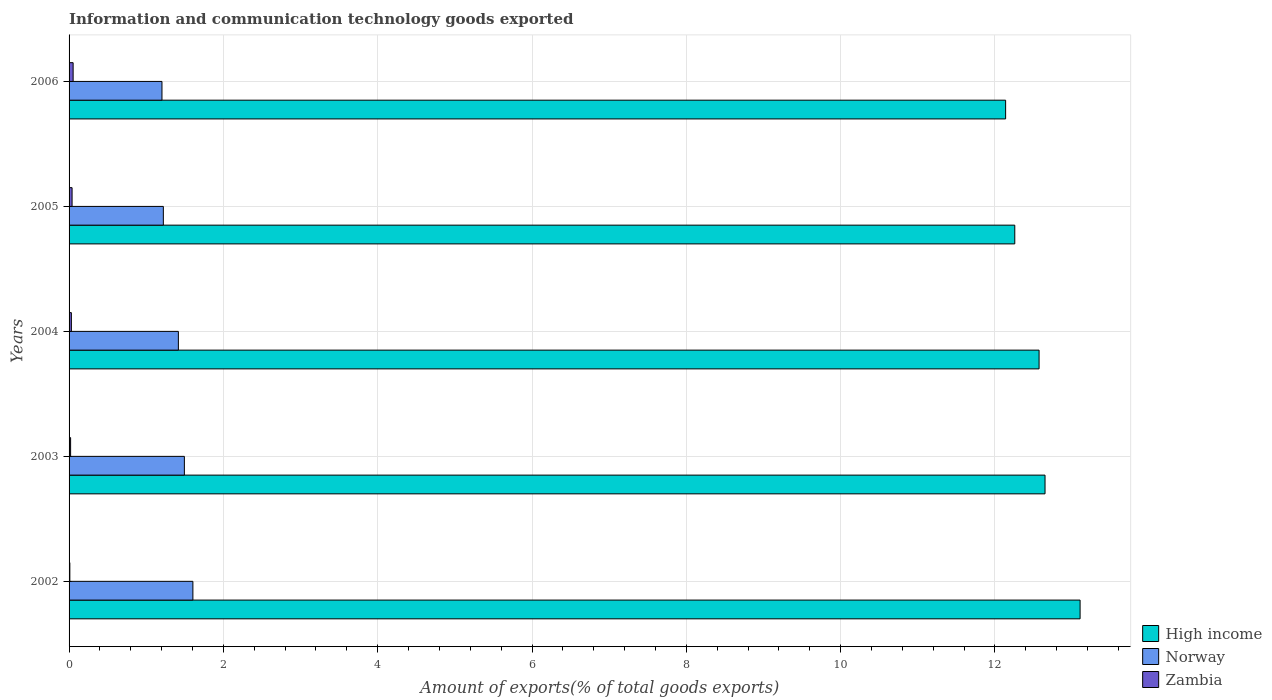How many groups of bars are there?
Your answer should be compact. 5. Are the number of bars on each tick of the Y-axis equal?
Make the answer very short. Yes. How many bars are there on the 5th tick from the top?
Give a very brief answer. 3. What is the label of the 3rd group of bars from the top?
Offer a very short reply. 2004. What is the amount of goods exported in Norway in 2003?
Make the answer very short. 1.49. Across all years, what is the maximum amount of goods exported in Zambia?
Keep it short and to the point. 0.05. Across all years, what is the minimum amount of goods exported in Zambia?
Your answer should be very brief. 0.01. In which year was the amount of goods exported in Norway minimum?
Give a very brief answer. 2006. What is the total amount of goods exported in Norway in the graph?
Keep it short and to the point. 6.94. What is the difference between the amount of goods exported in High income in 2002 and that in 2005?
Offer a terse response. 0.85. What is the difference between the amount of goods exported in Norway in 2004 and the amount of goods exported in Zambia in 2002?
Your answer should be very brief. 1.41. What is the average amount of goods exported in Zambia per year?
Your response must be concise. 0.03. In the year 2006, what is the difference between the amount of goods exported in High income and amount of goods exported in Zambia?
Give a very brief answer. 12.09. What is the ratio of the amount of goods exported in High income in 2004 to that in 2005?
Give a very brief answer. 1.03. Is the difference between the amount of goods exported in High income in 2002 and 2003 greater than the difference between the amount of goods exported in Zambia in 2002 and 2003?
Your response must be concise. Yes. What is the difference between the highest and the second highest amount of goods exported in High income?
Your answer should be compact. 0.45. What is the difference between the highest and the lowest amount of goods exported in High income?
Offer a terse response. 0.97. In how many years, is the amount of goods exported in Norway greater than the average amount of goods exported in Norway taken over all years?
Keep it short and to the point. 3. Is the sum of the amount of goods exported in Zambia in 2002 and 2003 greater than the maximum amount of goods exported in High income across all years?
Provide a succinct answer. No. What does the 1st bar from the top in 2005 represents?
Give a very brief answer. Zambia. What does the 1st bar from the bottom in 2005 represents?
Provide a short and direct response. High income. Is it the case that in every year, the sum of the amount of goods exported in Norway and amount of goods exported in High income is greater than the amount of goods exported in Zambia?
Ensure brevity in your answer.  Yes. How many bars are there?
Offer a terse response. 15. How many years are there in the graph?
Keep it short and to the point. 5. What is the difference between two consecutive major ticks on the X-axis?
Provide a succinct answer. 2. Are the values on the major ticks of X-axis written in scientific E-notation?
Make the answer very short. No. Where does the legend appear in the graph?
Offer a terse response. Bottom right. What is the title of the graph?
Your answer should be very brief. Information and communication technology goods exported. Does "Least developed countries" appear as one of the legend labels in the graph?
Your answer should be compact. No. What is the label or title of the X-axis?
Your answer should be very brief. Amount of exports(% of total goods exports). What is the label or title of the Y-axis?
Provide a short and direct response. Years. What is the Amount of exports(% of total goods exports) in High income in 2002?
Your response must be concise. 13.1. What is the Amount of exports(% of total goods exports) of Norway in 2002?
Provide a succinct answer. 1.6. What is the Amount of exports(% of total goods exports) in Zambia in 2002?
Provide a succinct answer. 0.01. What is the Amount of exports(% of total goods exports) of High income in 2003?
Give a very brief answer. 12.65. What is the Amount of exports(% of total goods exports) of Norway in 2003?
Your response must be concise. 1.49. What is the Amount of exports(% of total goods exports) in Zambia in 2003?
Offer a very short reply. 0.02. What is the Amount of exports(% of total goods exports) of High income in 2004?
Your answer should be very brief. 12.57. What is the Amount of exports(% of total goods exports) of Norway in 2004?
Your answer should be very brief. 1.42. What is the Amount of exports(% of total goods exports) in Zambia in 2004?
Provide a short and direct response. 0.03. What is the Amount of exports(% of total goods exports) of High income in 2005?
Offer a terse response. 12.26. What is the Amount of exports(% of total goods exports) of Norway in 2005?
Your answer should be compact. 1.22. What is the Amount of exports(% of total goods exports) of Zambia in 2005?
Provide a short and direct response. 0.04. What is the Amount of exports(% of total goods exports) in High income in 2006?
Offer a terse response. 12.14. What is the Amount of exports(% of total goods exports) in Norway in 2006?
Keep it short and to the point. 1.2. What is the Amount of exports(% of total goods exports) in Zambia in 2006?
Provide a succinct answer. 0.05. Across all years, what is the maximum Amount of exports(% of total goods exports) of High income?
Give a very brief answer. 13.1. Across all years, what is the maximum Amount of exports(% of total goods exports) of Norway?
Provide a short and direct response. 1.6. Across all years, what is the maximum Amount of exports(% of total goods exports) of Zambia?
Your response must be concise. 0.05. Across all years, what is the minimum Amount of exports(% of total goods exports) of High income?
Ensure brevity in your answer.  12.14. Across all years, what is the minimum Amount of exports(% of total goods exports) in Norway?
Provide a succinct answer. 1.2. Across all years, what is the minimum Amount of exports(% of total goods exports) of Zambia?
Provide a succinct answer. 0.01. What is the total Amount of exports(% of total goods exports) in High income in the graph?
Give a very brief answer. 62.72. What is the total Amount of exports(% of total goods exports) in Norway in the graph?
Provide a succinct answer. 6.94. What is the total Amount of exports(% of total goods exports) in Zambia in the graph?
Offer a very short reply. 0.15. What is the difference between the Amount of exports(% of total goods exports) of High income in 2002 and that in 2003?
Ensure brevity in your answer.  0.45. What is the difference between the Amount of exports(% of total goods exports) of Norway in 2002 and that in 2003?
Give a very brief answer. 0.11. What is the difference between the Amount of exports(% of total goods exports) in Zambia in 2002 and that in 2003?
Offer a terse response. -0.01. What is the difference between the Amount of exports(% of total goods exports) of High income in 2002 and that in 2004?
Your answer should be compact. 0.53. What is the difference between the Amount of exports(% of total goods exports) of Norway in 2002 and that in 2004?
Keep it short and to the point. 0.19. What is the difference between the Amount of exports(% of total goods exports) in Zambia in 2002 and that in 2004?
Give a very brief answer. -0.02. What is the difference between the Amount of exports(% of total goods exports) in High income in 2002 and that in 2005?
Offer a terse response. 0.85. What is the difference between the Amount of exports(% of total goods exports) in Norway in 2002 and that in 2005?
Make the answer very short. 0.38. What is the difference between the Amount of exports(% of total goods exports) of Zambia in 2002 and that in 2005?
Make the answer very short. -0.03. What is the difference between the Amount of exports(% of total goods exports) of High income in 2002 and that in 2006?
Your answer should be compact. 0.97. What is the difference between the Amount of exports(% of total goods exports) of Norway in 2002 and that in 2006?
Your answer should be compact. 0.4. What is the difference between the Amount of exports(% of total goods exports) in Zambia in 2002 and that in 2006?
Keep it short and to the point. -0.04. What is the difference between the Amount of exports(% of total goods exports) of High income in 2003 and that in 2004?
Offer a terse response. 0.08. What is the difference between the Amount of exports(% of total goods exports) of Norway in 2003 and that in 2004?
Your answer should be very brief. 0.08. What is the difference between the Amount of exports(% of total goods exports) of Zambia in 2003 and that in 2004?
Ensure brevity in your answer.  -0.01. What is the difference between the Amount of exports(% of total goods exports) in High income in 2003 and that in 2005?
Make the answer very short. 0.39. What is the difference between the Amount of exports(% of total goods exports) of Norway in 2003 and that in 2005?
Provide a short and direct response. 0.27. What is the difference between the Amount of exports(% of total goods exports) in Zambia in 2003 and that in 2005?
Your answer should be compact. -0.02. What is the difference between the Amount of exports(% of total goods exports) in High income in 2003 and that in 2006?
Keep it short and to the point. 0.51. What is the difference between the Amount of exports(% of total goods exports) in Norway in 2003 and that in 2006?
Provide a succinct answer. 0.29. What is the difference between the Amount of exports(% of total goods exports) of Zambia in 2003 and that in 2006?
Provide a short and direct response. -0.03. What is the difference between the Amount of exports(% of total goods exports) of High income in 2004 and that in 2005?
Keep it short and to the point. 0.31. What is the difference between the Amount of exports(% of total goods exports) of Norway in 2004 and that in 2005?
Ensure brevity in your answer.  0.19. What is the difference between the Amount of exports(% of total goods exports) in Zambia in 2004 and that in 2005?
Provide a succinct answer. -0.01. What is the difference between the Amount of exports(% of total goods exports) of High income in 2004 and that in 2006?
Make the answer very short. 0.43. What is the difference between the Amount of exports(% of total goods exports) of Norway in 2004 and that in 2006?
Keep it short and to the point. 0.21. What is the difference between the Amount of exports(% of total goods exports) in Zambia in 2004 and that in 2006?
Offer a very short reply. -0.02. What is the difference between the Amount of exports(% of total goods exports) of High income in 2005 and that in 2006?
Offer a terse response. 0.12. What is the difference between the Amount of exports(% of total goods exports) of Norway in 2005 and that in 2006?
Offer a very short reply. 0.02. What is the difference between the Amount of exports(% of total goods exports) in Zambia in 2005 and that in 2006?
Make the answer very short. -0.01. What is the difference between the Amount of exports(% of total goods exports) of High income in 2002 and the Amount of exports(% of total goods exports) of Norway in 2003?
Provide a short and direct response. 11.61. What is the difference between the Amount of exports(% of total goods exports) of High income in 2002 and the Amount of exports(% of total goods exports) of Zambia in 2003?
Keep it short and to the point. 13.08. What is the difference between the Amount of exports(% of total goods exports) in Norway in 2002 and the Amount of exports(% of total goods exports) in Zambia in 2003?
Provide a short and direct response. 1.58. What is the difference between the Amount of exports(% of total goods exports) of High income in 2002 and the Amount of exports(% of total goods exports) of Norway in 2004?
Keep it short and to the point. 11.69. What is the difference between the Amount of exports(% of total goods exports) in High income in 2002 and the Amount of exports(% of total goods exports) in Zambia in 2004?
Offer a very short reply. 13.07. What is the difference between the Amount of exports(% of total goods exports) in Norway in 2002 and the Amount of exports(% of total goods exports) in Zambia in 2004?
Provide a short and direct response. 1.57. What is the difference between the Amount of exports(% of total goods exports) in High income in 2002 and the Amount of exports(% of total goods exports) in Norway in 2005?
Provide a short and direct response. 11.88. What is the difference between the Amount of exports(% of total goods exports) in High income in 2002 and the Amount of exports(% of total goods exports) in Zambia in 2005?
Ensure brevity in your answer.  13.06. What is the difference between the Amount of exports(% of total goods exports) of Norway in 2002 and the Amount of exports(% of total goods exports) of Zambia in 2005?
Your answer should be compact. 1.57. What is the difference between the Amount of exports(% of total goods exports) in High income in 2002 and the Amount of exports(% of total goods exports) in Norway in 2006?
Your answer should be compact. 11.9. What is the difference between the Amount of exports(% of total goods exports) in High income in 2002 and the Amount of exports(% of total goods exports) in Zambia in 2006?
Ensure brevity in your answer.  13.05. What is the difference between the Amount of exports(% of total goods exports) of Norway in 2002 and the Amount of exports(% of total goods exports) of Zambia in 2006?
Offer a very short reply. 1.55. What is the difference between the Amount of exports(% of total goods exports) in High income in 2003 and the Amount of exports(% of total goods exports) in Norway in 2004?
Your answer should be very brief. 11.23. What is the difference between the Amount of exports(% of total goods exports) in High income in 2003 and the Amount of exports(% of total goods exports) in Zambia in 2004?
Your answer should be compact. 12.62. What is the difference between the Amount of exports(% of total goods exports) of Norway in 2003 and the Amount of exports(% of total goods exports) of Zambia in 2004?
Your answer should be compact. 1.46. What is the difference between the Amount of exports(% of total goods exports) in High income in 2003 and the Amount of exports(% of total goods exports) in Norway in 2005?
Keep it short and to the point. 11.43. What is the difference between the Amount of exports(% of total goods exports) in High income in 2003 and the Amount of exports(% of total goods exports) in Zambia in 2005?
Give a very brief answer. 12.61. What is the difference between the Amount of exports(% of total goods exports) in Norway in 2003 and the Amount of exports(% of total goods exports) in Zambia in 2005?
Ensure brevity in your answer.  1.46. What is the difference between the Amount of exports(% of total goods exports) of High income in 2003 and the Amount of exports(% of total goods exports) of Norway in 2006?
Keep it short and to the point. 11.45. What is the difference between the Amount of exports(% of total goods exports) in High income in 2003 and the Amount of exports(% of total goods exports) in Zambia in 2006?
Make the answer very short. 12.6. What is the difference between the Amount of exports(% of total goods exports) in Norway in 2003 and the Amount of exports(% of total goods exports) in Zambia in 2006?
Give a very brief answer. 1.44. What is the difference between the Amount of exports(% of total goods exports) in High income in 2004 and the Amount of exports(% of total goods exports) in Norway in 2005?
Provide a short and direct response. 11.35. What is the difference between the Amount of exports(% of total goods exports) in High income in 2004 and the Amount of exports(% of total goods exports) in Zambia in 2005?
Give a very brief answer. 12.53. What is the difference between the Amount of exports(% of total goods exports) of Norway in 2004 and the Amount of exports(% of total goods exports) of Zambia in 2005?
Offer a terse response. 1.38. What is the difference between the Amount of exports(% of total goods exports) of High income in 2004 and the Amount of exports(% of total goods exports) of Norway in 2006?
Make the answer very short. 11.37. What is the difference between the Amount of exports(% of total goods exports) of High income in 2004 and the Amount of exports(% of total goods exports) of Zambia in 2006?
Provide a short and direct response. 12.52. What is the difference between the Amount of exports(% of total goods exports) of Norway in 2004 and the Amount of exports(% of total goods exports) of Zambia in 2006?
Make the answer very short. 1.36. What is the difference between the Amount of exports(% of total goods exports) in High income in 2005 and the Amount of exports(% of total goods exports) in Norway in 2006?
Keep it short and to the point. 11.05. What is the difference between the Amount of exports(% of total goods exports) of High income in 2005 and the Amount of exports(% of total goods exports) of Zambia in 2006?
Make the answer very short. 12.2. What is the difference between the Amount of exports(% of total goods exports) in Norway in 2005 and the Amount of exports(% of total goods exports) in Zambia in 2006?
Make the answer very short. 1.17. What is the average Amount of exports(% of total goods exports) in High income per year?
Provide a succinct answer. 12.54. What is the average Amount of exports(% of total goods exports) in Norway per year?
Offer a terse response. 1.39. What is the average Amount of exports(% of total goods exports) of Zambia per year?
Make the answer very short. 0.03. In the year 2002, what is the difference between the Amount of exports(% of total goods exports) in High income and Amount of exports(% of total goods exports) in Norway?
Provide a short and direct response. 11.5. In the year 2002, what is the difference between the Amount of exports(% of total goods exports) of High income and Amount of exports(% of total goods exports) of Zambia?
Offer a terse response. 13.09. In the year 2002, what is the difference between the Amount of exports(% of total goods exports) in Norway and Amount of exports(% of total goods exports) in Zambia?
Your answer should be very brief. 1.59. In the year 2003, what is the difference between the Amount of exports(% of total goods exports) in High income and Amount of exports(% of total goods exports) in Norway?
Keep it short and to the point. 11.15. In the year 2003, what is the difference between the Amount of exports(% of total goods exports) in High income and Amount of exports(% of total goods exports) in Zambia?
Offer a very short reply. 12.63. In the year 2003, what is the difference between the Amount of exports(% of total goods exports) of Norway and Amount of exports(% of total goods exports) of Zambia?
Provide a succinct answer. 1.47. In the year 2004, what is the difference between the Amount of exports(% of total goods exports) of High income and Amount of exports(% of total goods exports) of Norway?
Your answer should be very brief. 11.16. In the year 2004, what is the difference between the Amount of exports(% of total goods exports) in High income and Amount of exports(% of total goods exports) in Zambia?
Provide a short and direct response. 12.54. In the year 2004, what is the difference between the Amount of exports(% of total goods exports) in Norway and Amount of exports(% of total goods exports) in Zambia?
Ensure brevity in your answer.  1.39. In the year 2005, what is the difference between the Amount of exports(% of total goods exports) of High income and Amount of exports(% of total goods exports) of Norway?
Provide a short and direct response. 11.04. In the year 2005, what is the difference between the Amount of exports(% of total goods exports) of High income and Amount of exports(% of total goods exports) of Zambia?
Your answer should be compact. 12.22. In the year 2005, what is the difference between the Amount of exports(% of total goods exports) of Norway and Amount of exports(% of total goods exports) of Zambia?
Provide a succinct answer. 1.18. In the year 2006, what is the difference between the Amount of exports(% of total goods exports) of High income and Amount of exports(% of total goods exports) of Norway?
Provide a short and direct response. 10.93. In the year 2006, what is the difference between the Amount of exports(% of total goods exports) in High income and Amount of exports(% of total goods exports) in Zambia?
Make the answer very short. 12.09. In the year 2006, what is the difference between the Amount of exports(% of total goods exports) in Norway and Amount of exports(% of total goods exports) in Zambia?
Offer a terse response. 1.15. What is the ratio of the Amount of exports(% of total goods exports) of High income in 2002 to that in 2003?
Offer a very short reply. 1.04. What is the ratio of the Amount of exports(% of total goods exports) in Norway in 2002 to that in 2003?
Give a very brief answer. 1.07. What is the ratio of the Amount of exports(% of total goods exports) in Zambia in 2002 to that in 2003?
Make the answer very short. 0.5. What is the ratio of the Amount of exports(% of total goods exports) of High income in 2002 to that in 2004?
Offer a terse response. 1.04. What is the ratio of the Amount of exports(% of total goods exports) in Norway in 2002 to that in 2004?
Give a very brief answer. 1.13. What is the ratio of the Amount of exports(% of total goods exports) of Zambia in 2002 to that in 2004?
Ensure brevity in your answer.  0.33. What is the ratio of the Amount of exports(% of total goods exports) of High income in 2002 to that in 2005?
Provide a short and direct response. 1.07. What is the ratio of the Amount of exports(% of total goods exports) in Norway in 2002 to that in 2005?
Offer a terse response. 1.31. What is the ratio of the Amount of exports(% of total goods exports) of Zambia in 2002 to that in 2005?
Offer a very short reply. 0.26. What is the ratio of the Amount of exports(% of total goods exports) in High income in 2002 to that in 2006?
Offer a terse response. 1.08. What is the ratio of the Amount of exports(% of total goods exports) in Norway in 2002 to that in 2006?
Your answer should be very brief. 1.33. What is the ratio of the Amount of exports(% of total goods exports) in Zambia in 2002 to that in 2006?
Your answer should be very brief. 0.19. What is the ratio of the Amount of exports(% of total goods exports) of High income in 2003 to that in 2004?
Keep it short and to the point. 1.01. What is the ratio of the Amount of exports(% of total goods exports) of Norway in 2003 to that in 2004?
Make the answer very short. 1.05. What is the ratio of the Amount of exports(% of total goods exports) in Zambia in 2003 to that in 2004?
Your response must be concise. 0.67. What is the ratio of the Amount of exports(% of total goods exports) in High income in 2003 to that in 2005?
Offer a terse response. 1.03. What is the ratio of the Amount of exports(% of total goods exports) of Norway in 2003 to that in 2005?
Offer a terse response. 1.22. What is the ratio of the Amount of exports(% of total goods exports) in Zambia in 2003 to that in 2005?
Provide a short and direct response. 0.51. What is the ratio of the Amount of exports(% of total goods exports) in High income in 2003 to that in 2006?
Make the answer very short. 1.04. What is the ratio of the Amount of exports(% of total goods exports) in Norway in 2003 to that in 2006?
Your response must be concise. 1.24. What is the ratio of the Amount of exports(% of total goods exports) in Zambia in 2003 to that in 2006?
Provide a short and direct response. 0.38. What is the ratio of the Amount of exports(% of total goods exports) of High income in 2004 to that in 2005?
Your answer should be very brief. 1.03. What is the ratio of the Amount of exports(% of total goods exports) of Norway in 2004 to that in 2005?
Give a very brief answer. 1.16. What is the ratio of the Amount of exports(% of total goods exports) of Zambia in 2004 to that in 2005?
Make the answer very short. 0.77. What is the ratio of the Amount of exports(% of total goods exports) of High income in 2004 to that in 2006?
Ensure brevity in your answer.  1.04. What is the ratio of the Amount of exports(% of total goods exports) in Norway in 2004 to that in 2006?
Offer a very short reply. 1.18. What is the ratio of the Amount of exports(% of total goods exports) in Zambia in 2004 to that in 2006?
Provide a succinct answer. 0.57. What is the ratio of the Amount of exports(% of total goods exports) of High income in 2005 to that in 2006?
Your answer should be very brief. 1.01. What is the ratio of the Amount of exports(% of total goods exports) in Norway in 2005 to that in 2006?
Provide a short and direct response. 1.01. What is the ratio of the Amount of exports(% of total goods exports) of Zambia in 2005 to that in 2006?
Your answer should be very brief. 0.74. What is the difference between the highest and the second highest Amount of exports(% of total goods exports) in High income?
Your answer should be very brief. 0.45. What is the difference between the highest and the second highest Amount of exports(% of total goods exports) of Norway?
Offer a terse response. 0.11. What is the difference between the highest and the second highest Amount of exports(% of total goods exports) of Zambia?
Make the answer very short. 0.01. What is the difference between the highest and the lowest Amount of exports(% of total goods exports) of High income?
Your answer should be compact. 0.97. What is the difference between the highest and the lowest Amount of exports(% of total goods exports) in Norway?
Provide a succinct answer. 0.4. What is the difference between the highest and the lowest Amount of exports(% of total goods exports) in Zambia?
Your answer should be compact. 0.04. 